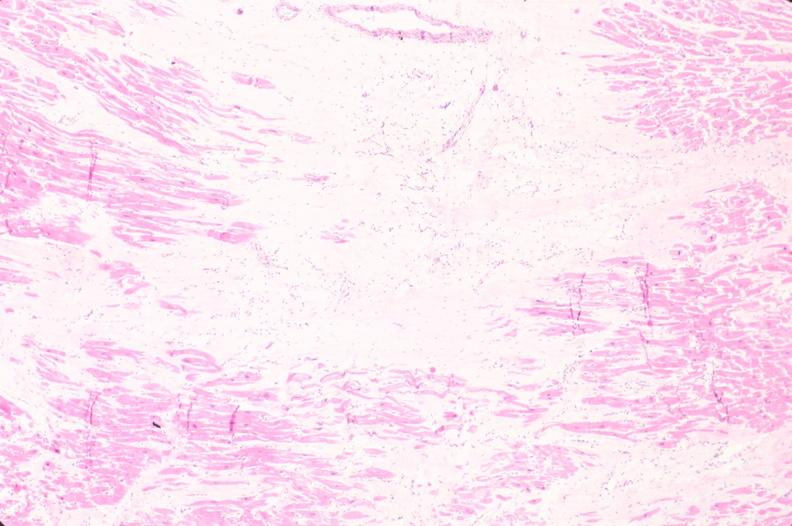s cardiovascular present?
Answer the question using a single word or phrase. Yes 